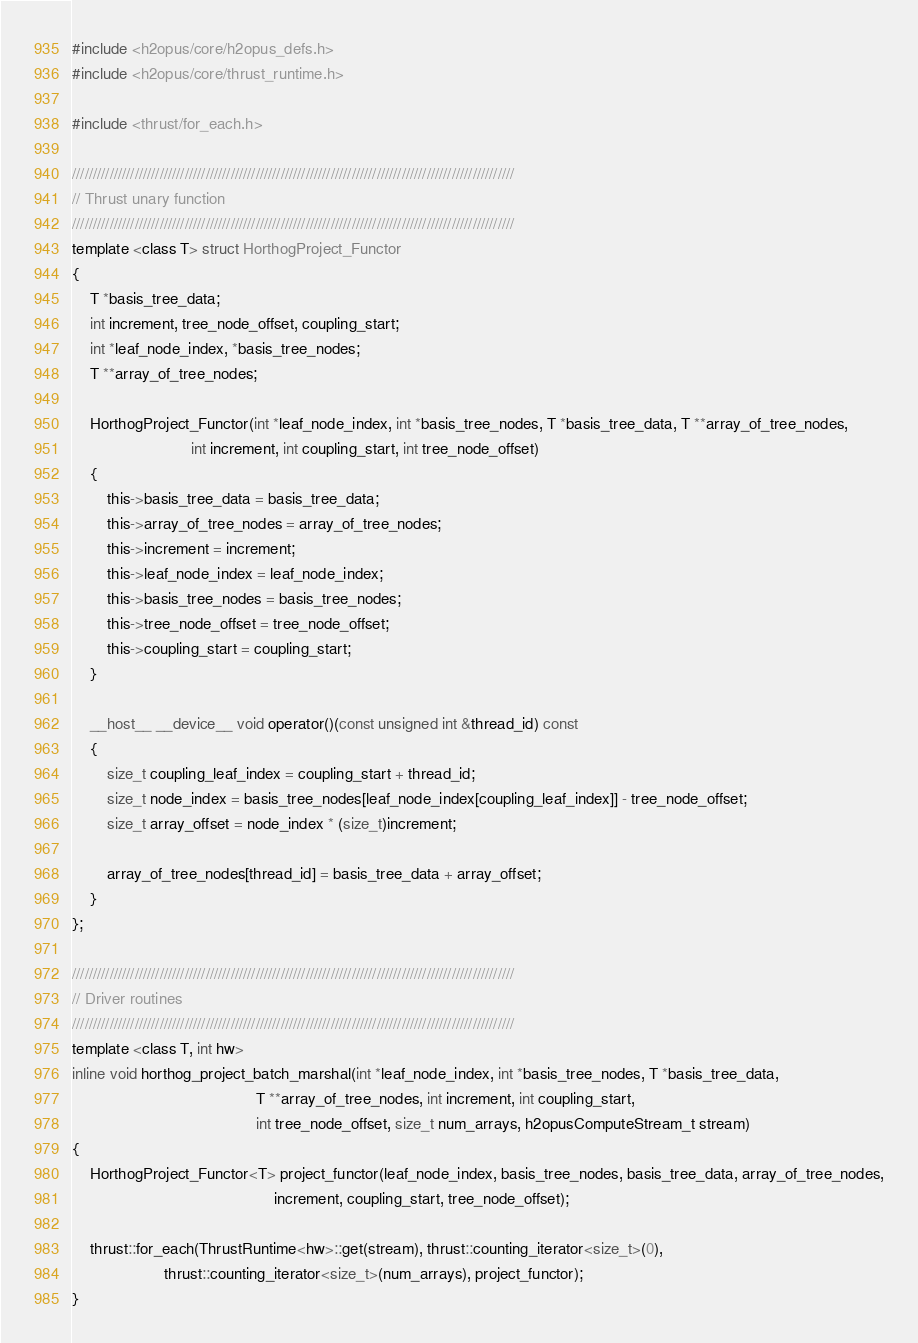Convert code to text. <code><loc_0><loc_0><loc_500><loc_500><_Cuda_>#include <h2opus/core/h2opus_defs.h>
#include <h2opus/core/thrust_runtime.h>

#include <thrust/for_each.h>

//////////////////////////////////////////////////////////////////////////////////////////////////////////
// Thrust unary function
//////////////////////////////////////////////////////////////////////////////////////////////////////////
template <class T> struct HorthogProject_Functor
{
    T *basis_tree_data;
    int increment, tree_node_offset, coupling_start;
    int *leaf_node_index, *basis_tree_nodes;
    T **array_of_tree_nodes;

    HorthogProject_Functor(int *leaf_node_index, int *basis_tree_nodes, T *basis_tree_data, T **array_of_tree_nodes,
                           int increment, int coupling_start, int tree_node_offset)
    {
        this->basis_tree_data = basis_tree_data;
        this->array_of_tree_nodes = array_of_tree_nodes;
        this->increment = increment;
        this->leaf_node_index = leaf_node_index;
        this->basis_tree_nodes = basis_tree_nodes;
        this->tree_node_offset = tree_node_offset;
        this->coupling_start = coupling_start;
    }

    __host__ __device__ void operator()(const unsigned int &thread_id) const
    {
        size_t coupling_leaf_index = coupling_start + thread_id;
        size_t node_index = basis_tree_nodes[leaf_node_index[coupling_leaf_index]] - tree_node_offset;
        size_t array_offset = node_index * (size_t)increment;

        array_of_tree_nodes[thread_id] = basis_tree_data + array_offset;
    }
};

//////////////////////////////////////////////////////////////////////////////////////////////////////////
// Driver routines
//////////////////////////////////////////////////////////////////////////////////////////////////////////
template <class T, int hw>
inline void horthog_project_batch_marshal(int *leaf_node_index, int *basis_tree_nodes, T *basis_tree_data,
                                          T **array_of_tree_nodes, int increment, int coupling_start,
                                          int tree_node_offset, size_t num_arrays, h2opusComputeStream_t stream)
{
    HorthogProject_Functor<T> project_functor(leaf_node_index, basis_tree_nodes, basis_tree_data, array_of_tree_nodes,
                                              increment, coupling_start, tree_node_offset);

    thrust::for_each(ThrustRuntime<hw>::get(stream), thrust::counting_iterator<size_t>(0),
                     thrust::counting_iterator<size_t>(num_arrays), project_functor);
}
</code> 